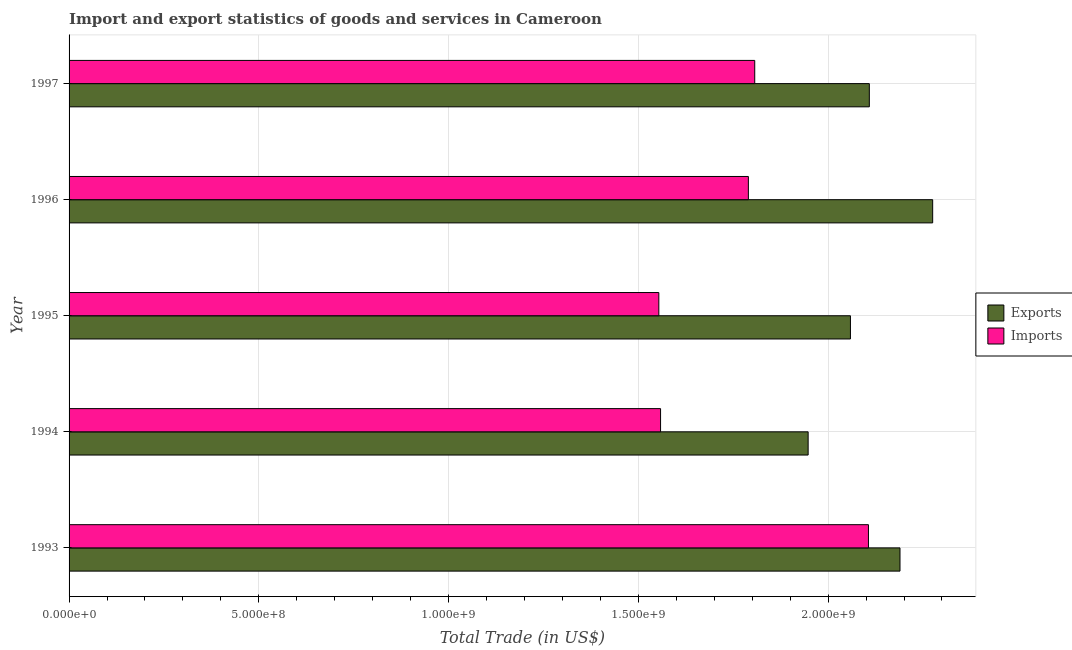How many different coloured bars are there?
Provide a short and direct response. 2. How many groups of bars are there?
Offer a very short reply. 5. Are the number of bars per tick equal to the number of legend labels?
Provide a succinct answer. Yes. How many bars are there on the 1st tick from the top?
Keep it short and to the point. 2. How many bars are there on the 3rd tick from the bottom?
Give a very brief answer. 2. In how many cases, is the number of bars for a given year not equal to the number of legend labels?
Ensure brevity in your answer.  0. What is the imports of goods and services in 1997?
Offer a terse response. 1.81e+09. Across all years, what is the maximum imports of goods and services?
Provide a succinct answer. 2.11e+09. Across all years, what is the minimum export of goods and services?
Your response must be concise. 1.95e+09. In which year was the export of goods and services maximum?
Your response must be concise. 1996. In which year was the export of goods and services minimum?
Offer a very short reply. 1994. What is the total imports of goods and services in the graph?
Keep it short and to the point. 8.82e+09. What is the difference between the imports of goods and services in 1995 and that in 1996?
Keep it short and to the point. -2.36e+08. What is the difference between the export of goods and services in 1995 and the imports of goods and services in 1994?
Your answer should be compact. 5.00e+08. What is the average imports of goods and services per year?
Ensure brevity in your answer.  1.76e+09. In the year 1993, what is the difference between the export of goods and services and imports of goods and services?
Provide a short and direct response. 8.31e+07. In how many years, is the export of goods and services greater than 400000000 US$?
Your response must be concise. 5. What is the ratio of the export of goods and services in 1996 to that in 1997?
Ensure brevity in your answer.  1.08. Is the export of goods and services in 1995 less than that in 1996?
Provide a short and direct response. Yes. Is the difference between the export of goods and services in 1993 and 1994 greater than the difference between the imports of goods and services in 1993 and 1994?
Give a very brief answer. No. What is the difference between the highest and the second highest imports of goods and services?
Offer a very short reply. 3.00e+08. What is the difference between the highest and the lowest export of goods and services?
Provide a succinct answer. 3.28e+08. In how many years, is the imports of goods and services greater than the average imports of goods and services taken over all years?
Provide a short and direct response. 3. What does the 1st bar from the top in 1995 represents?
Provide a short and direct response. Imports. What does the 2nd bar from the bottom in 1994 represents?
Make the answer very short. Imports. How many years are there in the graph?
Give a very brief answer. 5. Does the graph contain any zero values?
Offer a terse response. No. Where does the legend appear in the graph?
Provide a short and direct response. Center right. What is the title of the graph?
Offer a very short reply. Import and export statistics of goods and services in Cameroon. Does "Total Population" appear as one of the legend labels in the graph?
Ensure brevity in your answer.  No. What is the label or title of the X-axis?
Your answer should be compact. Total Trade (in US$). What is the Total Trade (in US$) in Exports in 1993?
Provide a succinct answer. 2.19e+09. What is the Total Trade (in US$) of Imports in 1993?
Provide a succinct answer. 2.11e+09. What is the Total Trade (in US$) in Exports in 1994?
Your answer should be compact. 1.95e+09. What is the Total Trade (in US$) in Imports in 1994?
Keep it short and to the point. 1.56e+09. What is the Total Trade (in US$) in Exports in 1995?
Provide a succinct answer. 2.06e+09. What is the Total Trade (in US$) of Imports in 1995?
Ensure brevity in your answer.  1.55e+09. What is the Total Trade (in US$) in Exports in 1996?
Offer a very short reply. 2.28e+09. What is the Total Trade (in US$) of Imports in 1996?
Provide a succinct answer. 1.79e+09. What is the Total Trade (in US$) in Exports in 1997?
Provide a short and direct response. 2.11e+09. What is the Total Trade (in US$) in Imports in 1997?
Your answer should be very brief. 1.81e+09. Across all years, what is the maximum Total Trade (in US$) of Exports?
Make the answer very short. 2.28e+09. Across all years, what is the maximum Total Trade (in US$) of Imports?
Provide a short and direct response. 2.11e+09. Across all years, what is the minimum Total Trade (in US$) in Exports?
Provide a short and direct response. 1.95e+09. Across all years, what is the minimum Total Trade (in US$) of Imports?
Your response must be concise. 1.55e+09. What is the total Total Trade (in US$) in Exports in the graph?
Provide a short and direct response. 1.06e+1. What is the total Total Trade (in US$) of Imports in the graph?
Provide a short and direct response. 8.82e+09. What is the difference between the Total Trade (in US$) of Exports in 1993 and that in 1994?
Your answer should be compact. 2.42e+08. What is the difference between the Total Trade (in US$) in Imports in 1993 and that in 1994?
Your answer should be very brief. 5.48e+08. What is the difference between the Total Trade (in US$) of Exports in 1993 and that in 1995?
Your answer should be very brief. 1.31e+08. What is the difference between the Total Trade (in US$) of Imports in 1993 and that in 1995?
Make the answer very short. 5.52e+08. What is the difference between the Total Trade (in US$) of Exports in 1993 and that in 1996?
Make the answer very short. -8.61e+07. What is the difference between the Total Trade (in US$) in Imports in 1993 and that in 1996?
Your answer should be very brief. 3.16e+08. What is the difference between the Total Trade (in US$) of Exports in 1993 and that in 1997?
Give a very brief answer. 8.08e+07. What is the difference between the Total Trade (in US$) of Imports in 1993 and that in 1997?
Give a very brief answer. 3.00e+08. What is the difference between the Total Trade (in US$) in Exports in 1994 and that in 1995?
Your response must be concise. -1.11e+08. What is the difference between the Total Trade (in US$) in Imports in 1994 and that in 1995?
Offer a terse response. 4.59e+06. What is the difference between the Total Trade (in US$) of Exports in 1994 and that in 1996?
Offer a very short reply. -3.28e+08. What is the difference between the Total Trade (in US$) in Imports in 1994 and that in 1996?
Your answer should be very brief. -2.31e+08. What is the difference between the Total Trade (in US$) in Exports in 1994 and that in 1997?
Ensure brevity in your answer.  -1.61e+08. What is the difference between the Total Trade (in US$) in Imports in 1994 and that in 1997?
Give a very brief answer. -2.48e+08. What is the difference between the Total Trade (in US$) in Exports in 1995 and that in 1996?
Your answer should be compact. -2.17e+08. What is the difference between the Total Trade (in US$) in Imports in 1995 and that in 1996?
Your answer should be very brief. -2.36e+08. What is the difference between the Total Trade (in US$) in Exports in 1995 and that in 1997?
Your response must be concise. -4.98e+07. What is the difference between the Total Trade (in US$) of Imports in 1995 and that in 1997?
Keep it short and to the point. -2.53e+08. What is the difference between the Total Trade (in US$) in Exports in 1996 and that in 1997?
Ensure brevity in your answer.  1.67e+08. What is the difference between the Total Trade (in US$) in Imports in 1996 and that in 1997?
Give a very brief answer. -1.68e+07. What is the difference between the Total Trade (in US$) of Exports in 1993 and the Total Trade (in US$) of Imports in 1994?
Provide a short and direct response. 6.31e+08. What is the difference between the Total Trade (in US$) of Exports in 1993 and the Total Trade (in US$) of Imports in 1995?
Your response must be concise. 6.35e+08. What is the difference between the Total Trade (in US$) of Exports in 1993 and the Total Trade (in US$) of Imports in 1996?
Offer a terse response. 4.00e+08. What is the difference between the Total Trade (in US$) in Exports in 1993 and the Total Trade (in US$) in Imports in 1997?
Your answer should be very brief. 3.83e+08. What is the difference between the Total Trade (in US$) in Exports in 1994 and the Total Trade (in US$) in Imports in 1995?
Offer a very short reply. 3.93e+08. What is the difference between the Total Trade (in US$) in Exports in 1994 and the Total Trade (in US$) in Imports in 1996?
Provide a short and direct response. 1.58e+08. What is the difference between the Total Trade (in US$) in Exports in 1994 and the Total Trade (in US$) in Imports in 1997?
Your answer should be very brief. 1.41e+08. What is the difference between the Total Trade (in US$) of Exports in 1995 and the Total Trade (in US$) of Imports in 1996?
Offer a terse response. 2.69e+08. What is the difference between the Total Trade (in US$) in Exports in 1995 and the Total Trade (in US$) in Imports in 1997?
Offer a very short reply. 2.52e+08. What is the difference between the Total Trade (in US$) in Exports in 1996 and the Total Trade (in US$) in Imports in 1997?
Keep it short and to the point. 4.69e+08. What is the average Total Trade (in US$) in Exports per year?
Offer a very short reply. 2.12e+09. What is the average Total Trade (in US$) of Imports per year?
Your answer should be very brief. 1.76e+09. In the year 1993, what is the difference between the Total Trade (in US$) of Exports and Total Trade (in US$) of Imports?
Offer a terse response. 8.31e+07. In the year 1994, what is the difference between the Total Trade (in US$) in Exports and Total Trade (in US$) in Imports?
Your answer should be compact. 3.89e+08. In the year 1995, what is the difference between the Total Trade (in US$) in Exports and Total Trade (in US$) in Imports?
Your response must be concise. 5.05e+08. In the year 1996, what is the difference between the Total Trade (in US$) in Exports and Total Trade (in US$) in Imports?
Ensure brevity in your answer.  4.86e+08. In the year 1997, what is the difference between the Total Trade (in US$) of Exports and Total Trade (in US$) of Imports?
Offer a terse response. 3.02e+08. What is the ratio of the Total Trade (in US$) in Exports in 1993 to that in 1994?
Your answer should be compact. 1.12. What is the ratio of the Total Trade (in US$) in Imports in 1993 to that in 1994?
Provide a succinct answer. 1.35. What is the ratio of the Total Trade (in US$) in Exports in 1993 to that in 1995?
Your response must be concise. 1.06. What is the ratio of the Total Trade (in US$) of Imports in 1993 to that in 1995?
Keep it short and to the point. 1.36. What is the ratio of the Total Trade (in US$) of Exports in 1993 to that in 1996?
Provide a succinct answer. 0.96. What is the ratio of the Total Trade (in US$) of Imports in 1993 to that in 1996?
Give a very brief answer. 1.18. What is the ratio of the Total Trade (in US$) in Exports in 1993 to that in 1997?
Make the answer very short. 1.04. What is the ratio of the Total Trade (in US$) in Imports in 1993 to that in 1997?
Your response must be concise. 1.17. What is the ratio of the Total Trade (in US$) of Exports in 1994 to that in 1995?
Make the answer very short. 0.95. What is the ratio of the Total Trade (in US$) of Imports in 1994 to that in 1995?
Give a very brief answer. 1. What is the ratio of the Total Trade (in US$) in Exports in 1994 to that in 1996?
Ensure brevity in your answer.  0.86. What is the ratio of the Total Trade (in US$) in Imports in 1994 to that in 1996?
Make the answer very short. 0.87. What is the ratio of the Total Trade (in US$) of Exports in 1994 to that in 1997?
Provide a short and direct response. 0.92. What is the ratio of the Total Trade (in US$) of Imports in 1994 to that in 1997?
Offer a very short reply. 0.86. What is the ratio of the Total Trade (in US$) in Exports in 1995 to that in 1996?
Your response must be concise. 0.9. What is the ratio of the Total Trade (in US$) in Imports in 1995 to that in 1996?
Offer a terse response. 0.87. What is the ratio of the Total Trade (in US$) in Exports in 1995 to that in 1997?
Make the answer very short. 0.98. What is the ratio of the Total Trade (in US$) of Imports in 1995 to that in 1997?
Offer a very short reply. 0.86. What is the ratio of the Total Trade (in US$) of Exports in 1996 to that in 1997?
Your response must be concise. 1.08. What is the ratio of the Total Trade (in US$) of Imports in 1996 to that in 1997?
Provide a succinct answer. 0.99. What is the difference between the highest and the second highest Total Trade (in US$) of Exports?
Ensure brevity in your answer.  8.61e+07. What is the difference between the highest and the second highest Total Trade (in US$) of Imports?
Make the answer very short. 3.00e+08. What is the difference between the highest and the lowest Total Trade (in US$) in Exports?
Offer a terse response. 3.28e+08. What is the difference between the highest and the lowest Total Trade (in US$) in Imports?
Offer a very short reply. 5.52e+08. 